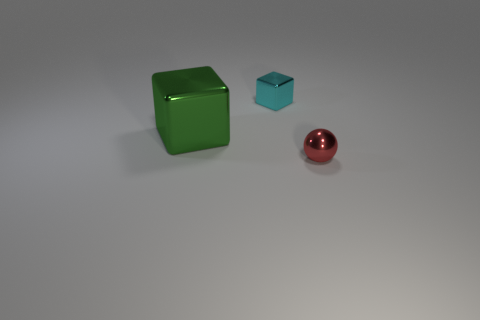Add 1 large green metallic blocks. How many objects exist? 4 Subtract all cubes. How many objects are left? 1 Add 3 big red metallic balls. How many big red metallic balls exist? 3 Subtract 0 gray spheres. How many objects are left? 3 Subtract all tiny red objects. Subtract all small red things. How many objects are left? 1 Add 3 cyan blocks. How many cyan blocks are left? 4 